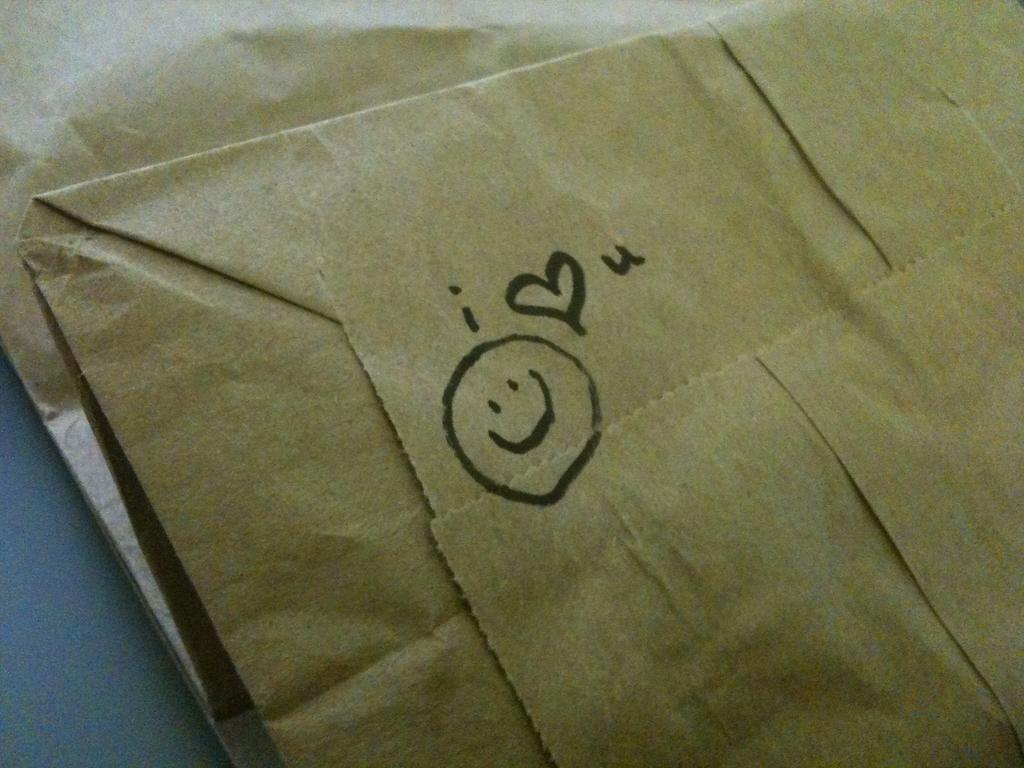Provide a one-sentence caption for the provided image. A paper bag with a smiley face and "i <3 u" drawn on it. 